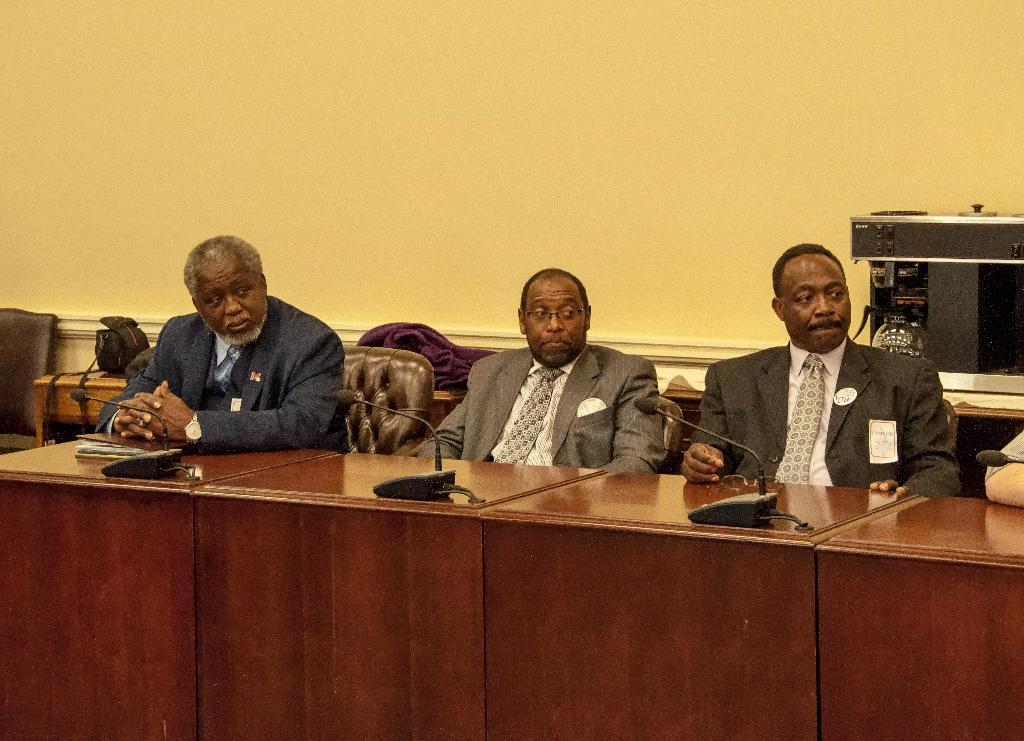How many people are sitting in the image? There are three persons sitting on chairs in the image. What furniture is visible in the image? Tables and chairs are present in the image. What objects are on the table? Microphones and at least one book are on the table. What can be seen in the background of the image? There is a wall in the background of the image. Can you tell me how many tramps are visible in the image? There are no tramps present in the image. Are there any cushions on the chairs in the image? The provided facts do not mention cushions on the chairs, so we cannot determine their presence from the image. 